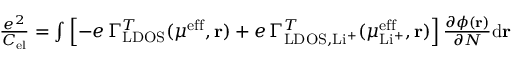Convert formula to latex. <formula><loc_0><loc_0><loc_500><loc_500>\begin{array} { r } { \frac { e ^ { 2 } } { C _ { e l } } = \int \left [ - e \, \Gamma _ { L D O S } ^ { T } ( \mu ^ { e f f } , r ) + e \, \Gamma _ { L D O S , L i ^ { + } } ^ { T } ( \mu _ { L i ^ { + } } ^ { e f f } , r ) \right ] \frac { \partial \phi ( r ) } { \partial N } d r } \end{array}</formula> 